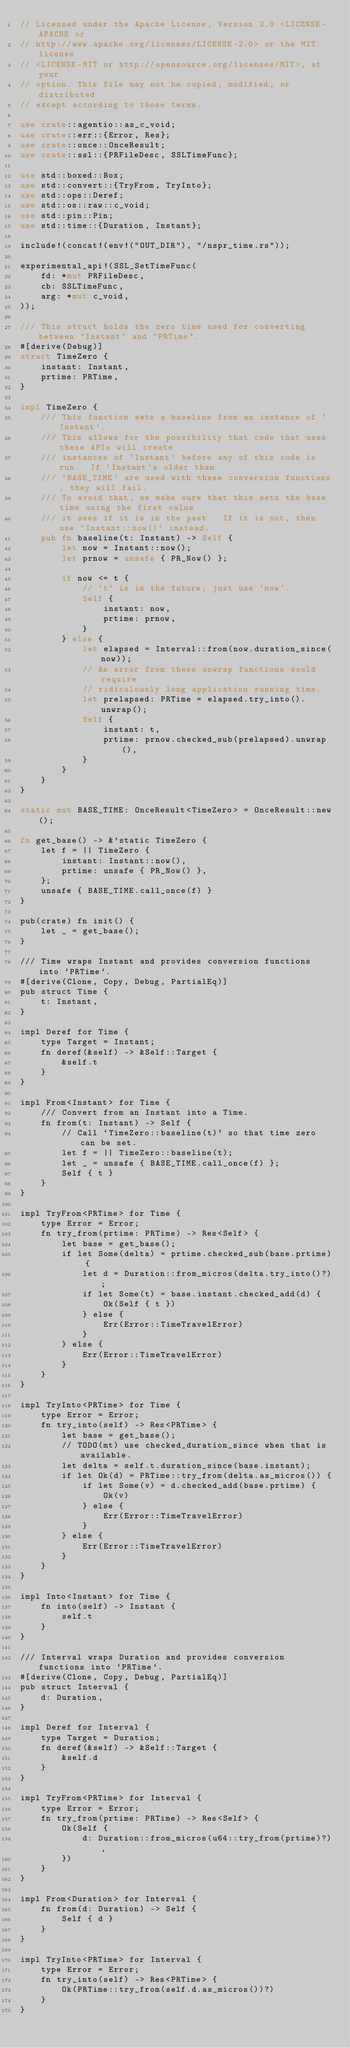<code> <loc_0><loc_0><loc_500><loc_500><_Rust_>// Licensed under the Apache License, Version 2.0 <LICENSE-APACHE or
// http://www.apache.org/licenses/LICENSE-2.0> or the MIT license
// <LICENSE-MIT or http://opensource.org/licenses/MIT>, at your
// option. This file may not be copied, modified, or distributed
// except according to those terms.

use crate::agentio::as_c_void;
use crate::err::{Error, Res};
use crate::once::OnceResult;
use crate::ssl::{PRFileDesc, SSLTimeFunc};

use std::boxed::Box;
use std::convert::{TryFrom, TryInto};
use std::ops::Deref;
use std::os::raw::c_void;
use std::pin::Pin;
use std::time::{Duration, Instant};

include!(concat!(env!("OUT_DIR"), "/nspr_time.rs"));

experimental_api!(SSL_SetTimeFunc(
    fd: *mut PRFileDesc,
    cb: SSLTimeFunc,
    arg: *mut c_void,
));

/// This struct holds the zero time used for converting between `Instant` and `PRTime`.
#[derive(Debug)]
struct TimeZero {
    instant: Instant,
    prtime: PRTime,
}

impl TimeZero {
    /// This function sets a baseline from an instance of `Instant`.
    /// This allows for the possibility that code that uses these APIs will create
    /// instances of `Instant` before any of this code is run.  If `Instant`s older than
    /// `BASE_TIME` are used with these conversion functions, they will fail.
    /// To avoid that, we make sure that this sets the base time using the first value
    /// it sees if it is in the past.  If it is not, then use `Instant::now()` instead.
    pub fn baseline(t: Instant) -> Self {
        let now = Instant::now();
        let prnow = unsafe { PR_Now() };

        if now <= t {
            // `t` is in the future, just use `now`.
            Self {
                instant: now,
                prtime: prnow,
            }
        } else {
            let elapsed = Interval::from(now.duration_since(now));
            // An error from these unwrap functions would require
            // ridiculously long application running time.
            let prelapsed: PRTime = elapsed.try_into().unwrap();
            Self {
                instant: t,
                prtime: prnow.checked_sub(prelapsed).unwrap(),
            }
        }
    }
}

static mut BASE_TIME: OnceResult<TimeZero> = OnceResult::new();

fn get_base() -> &'static TimeZero {
    let f = || TimeZero {
        instant: Instant::now(),
        prtime: unsafe { PR_Now() },
    };
    unsafe { BASE_TIME.call_once(f) }
}

pub(crate) fn init() {
    let _ = get_base();
}

/// Time wraps Instant and provides conversion functions into `PRTime`.
#[derive(Clone, Copy, Debug, PartialEq)]
pub struct Time {
    t: Instant,
}

impl Deref for Time {
    type Target = Instant;
    fn deref(&self) -> &Self::Target {
        &self.t
    }
}

impl From<Instant> for Time {
    /// Convert from an Instant into a Time.
    fn from(t: Instant) -> Self {
        // Call `TimeZero::baseline(t)` so that time zero can be set.
        let f = || TimeZero::baseline(t);
        let _ = unsafe { BASE_TIME.call_once(f) };
        Self { t }
    }
}

impl TryFrom<PRTime> for Time {
    type Error = Error;
    fn try_from(prtime: PRTime) -> Res<Self> {
        let base = get_base();
        if let Some(delta) = prtime.checked_sub(base.prtime) {
            let d = Duration::from_micros(delta.try_into()?);
            if let Some(t) = base.instant.checked_add(d) {
                Ok(Self { t })
            } else {
                Err(Error::TimeTravelError)
            }
        } else {
            Err(Error::TimeTravelError)
        }
    }
}

impl TryInto<PRTime> for Time {
    type Error = Error;
    fn try_into(self) -> Res<PRTime> {
        let base = get_base();
        // TODO(mt) use checked_duration_since when that is available.
        let delta = self.t.duration_since(base.instant);
        if let Ok(d) = PRTime::try_from(delta.as_micros()) {
            if let Some(v) = d.checked_add(base.prtime) {
                Ok(v)
            } else {
                Err(Error::TimeTravelError)
            }
        } else {
            Err(Error::TimeTravelError)
        }
    }
}

impl Into<Instant> for Time {
    fn into(self) -> Instant {
        self.t
    }
}

/// Interval wraps Duration and provides conversion functions into `PRTime`.
#[derive(Clone, Copy, Debug, PartialEq)]
pub struct Interval {
    d: Duration,
}

impl Deref for Interval {
    type Target = Duration;
    fn deref(&self) -> &Self::Target {
        &self.d
    }
}

impl TryFrom<PRTime> for Interval {
    type Error = Error;
    fn try_from(prtime: PRTime) -> Res<Self> {
        Ok(Self {
            d: Duration::from_micros(u64::try_from(prtime)?),
        })
    }
}

impl From<Duration> for Interval {
    fn from(d: Duration) -> Self {
        Self { d }
    }
}

impl TryInto<PRTime> for Interval {
    type Error = Error;
    fn try_into(self) -> Res<PRTime> {
        Ok(PRTime::try_from(self.d.as_micros())?)
    }
}
</code> 